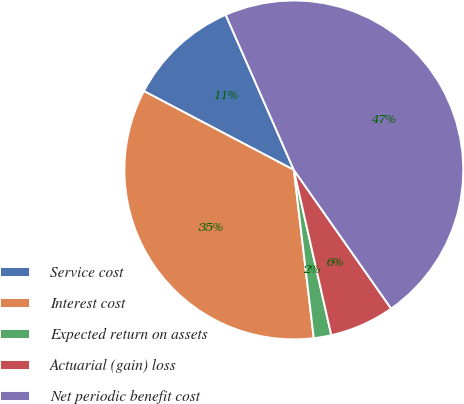Convert chart to OTSL. <chart><loc_0><loc_0><loc_500><loc_500><pie_chart><fcel>Service cost<fcel>Interest cost<fcel>Expected return on assets<fcel>Actuarial (gain) loss<fcel>Net periodic benefit cost<nl><fcel>10.71%<fcel>34.58%<fcel>1.67%<fcel>6.19%<fcel>46.85%<nl></chart> 